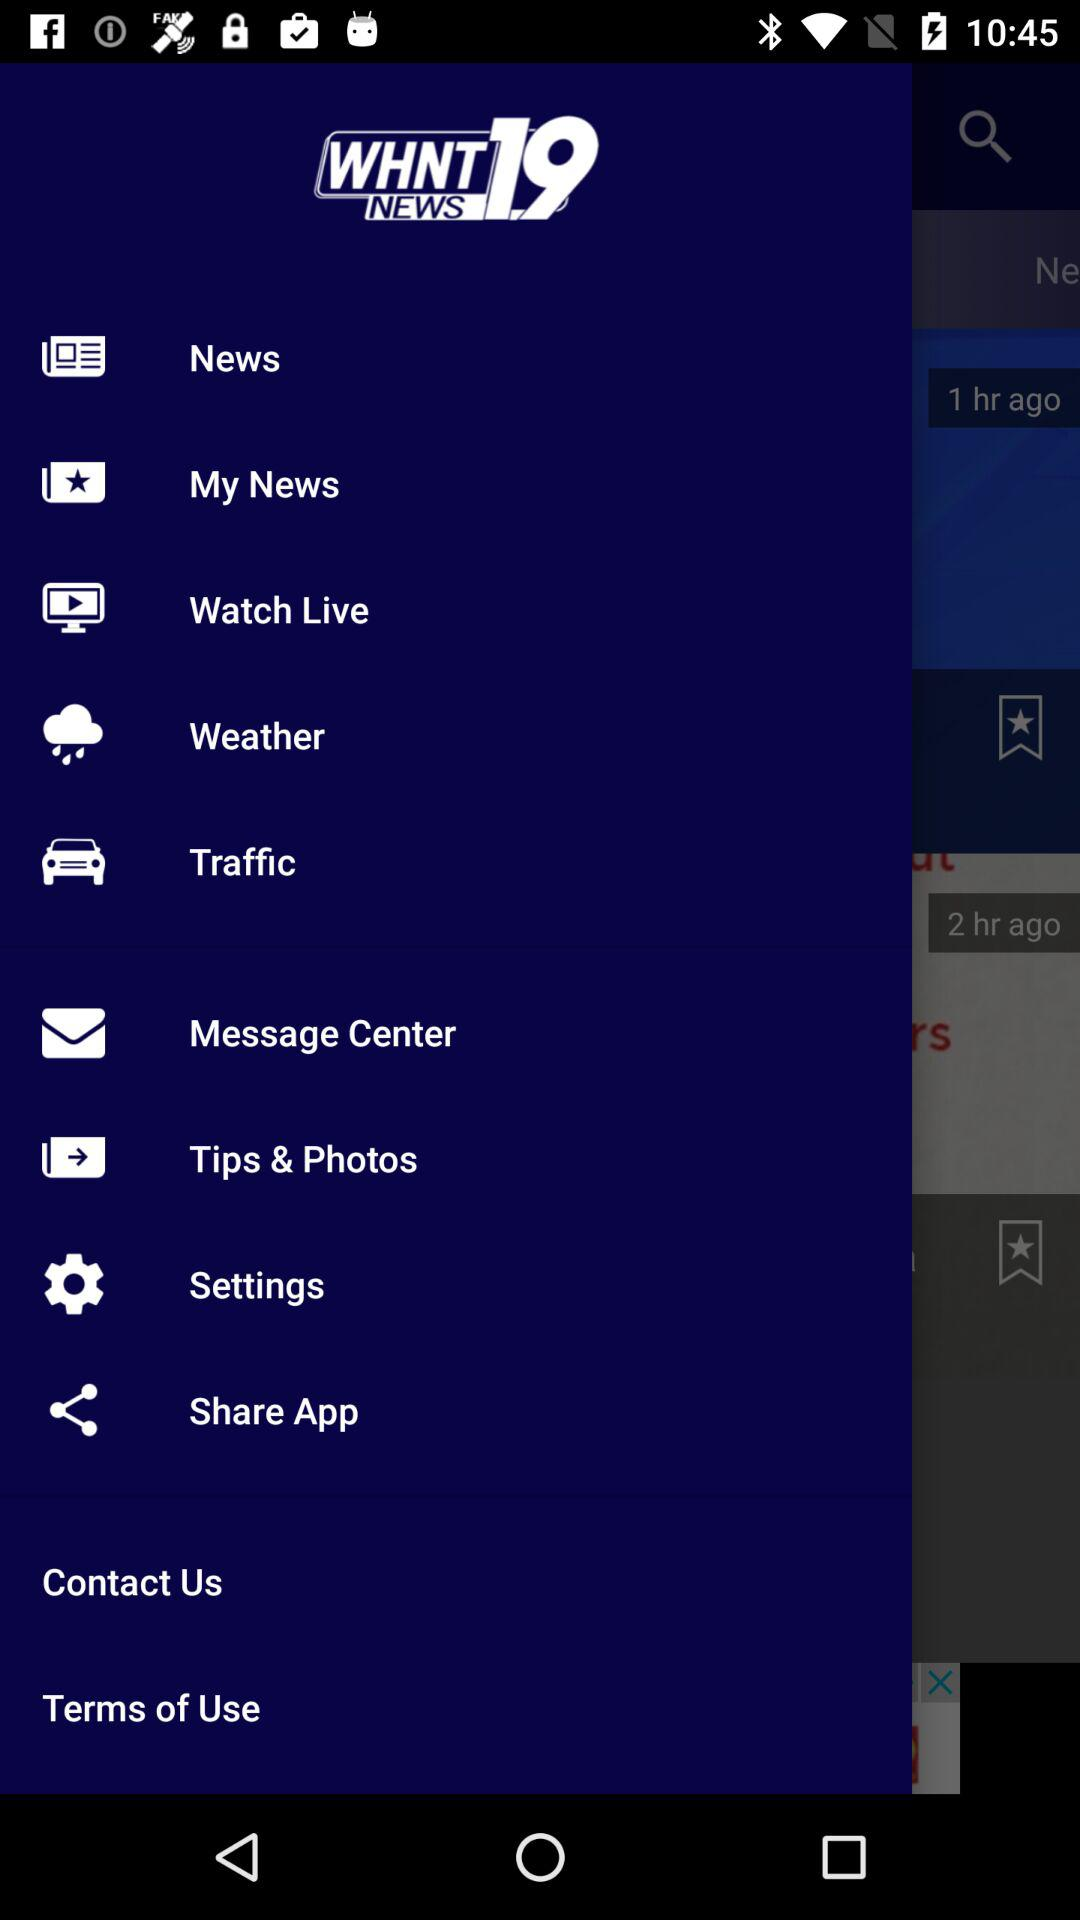Will it rain tomorrow?
When the provided information is insufficient, respond with <no answer>. <no answer> 